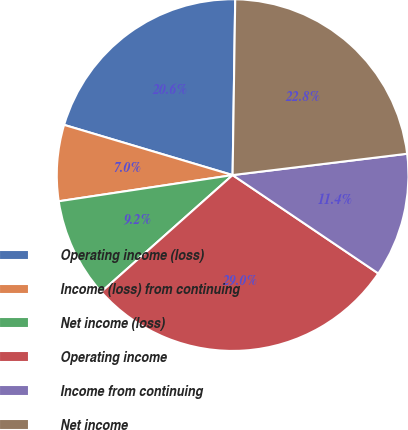Convert chart to OTSL. <chart><loc_0><loc_0><loc_500><loc_500><pie_chart><fcel>Operating income (loss)<fcel>Income (loss) from continuing<fcel>Net income (loss)<fcel>Operating income<fcel>Income from continuing<fcel>Net income<nl><fcel>20.63%<fcel>6.99%<fcel>9.19%<fcel>28.98%<fcel>11.39%<fcel>22.83%<nl></chart> 